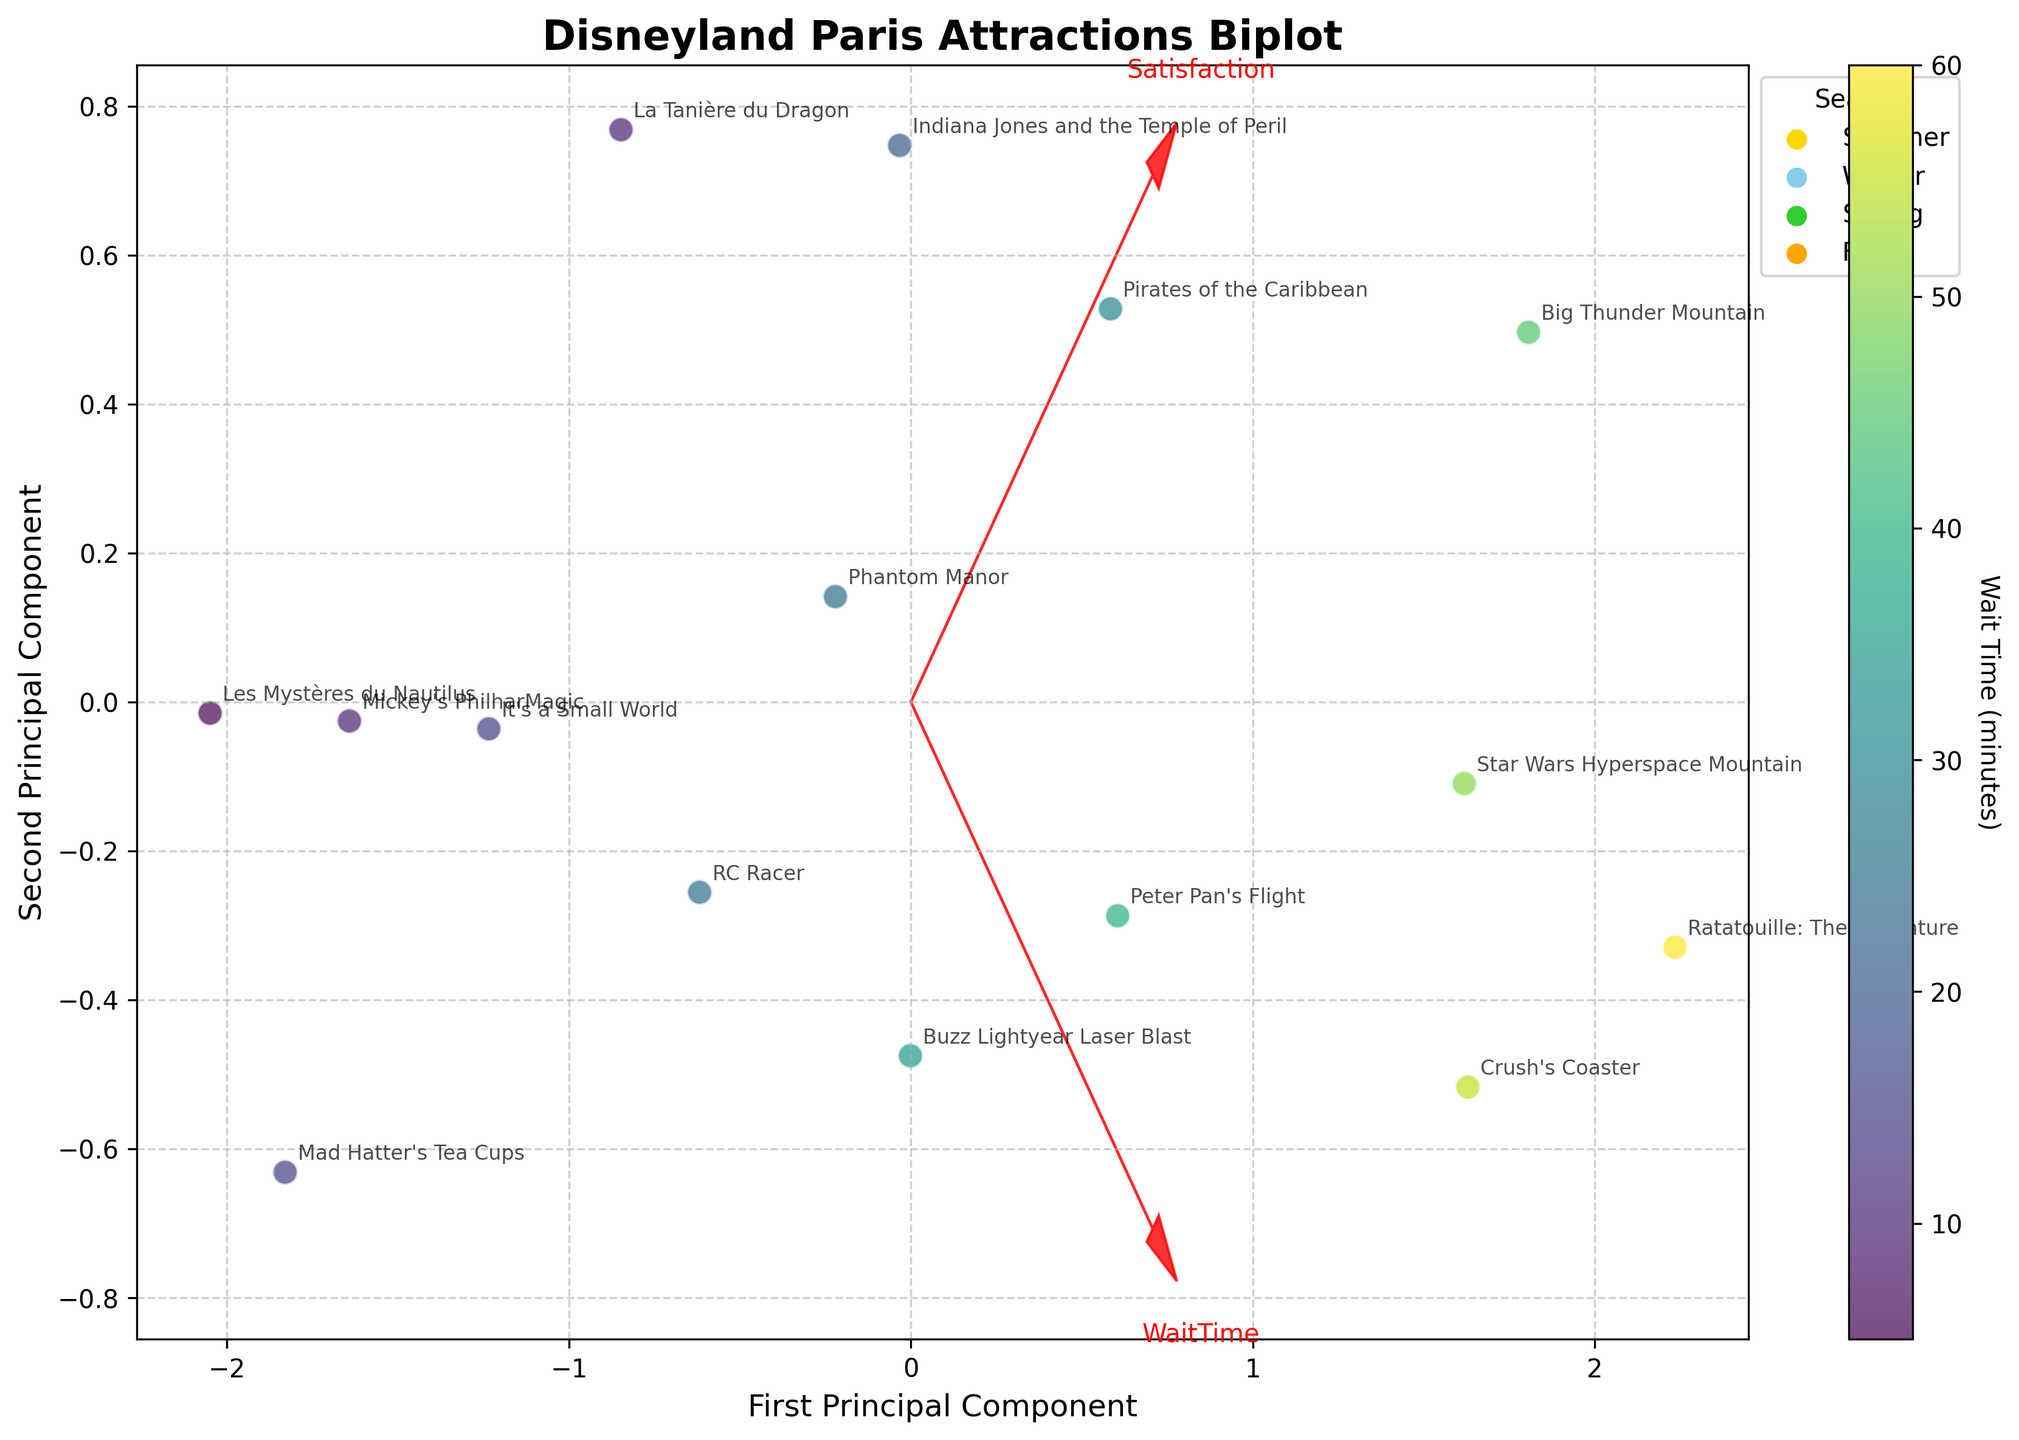What does the arrow represent in the biplot? The arrows in the biplot represent the directions of the features (Satisfaction and WaitTime) in the new principal component space. Each arrow points in the direction of the greatest variance for that feature.
Answer: Feature direction How can we identify which attractions have the highest satisfaction ratings? In the biplot, data points representing attractions can be identified with their labels. The position of each point along the axis direction helps in identifying their corresponding satisfaction ratings. Attractions positioned farther in the direction of the arrow labeled "Satisfaction" have higher satisfaction ratings.
Answer: By looking at the position along the Satisfaction direction How does 'Big Thunder Mountain' compare to 'Peter Pan's Flight' in terms of wait time? The biplot allows us to compare wait times by observing their positions relative to the "WaitTime" arrow. 'Big Thunder Mountain' and 'Peter Pan's Flight' can be compared by seeing which point is closer to the end of the "WaitTime" arrow. 'Big Thunder Mountain' is closer to the high end of the wait time direction compared to 'Peter Pan's Flight'.
Answer: 'Big Thunder Mountain' has a higher wait time Which season has the most data points in the biplot? The color legend indicates different seasons with distinctive colors. Counting the number of data points per color in the scatter plot, the season with the most points can be identified.
Answer: Summer Why does 'Les Mystères du Nautilus' have a lower satisfaction rating compared to 'Star Wars Hyperspace Mountain'? From the biplot, compare the relative positions of the data points labeled 'Les Mystères du Nautilus' and 'Star Wars Hyperspace Mountain' along the Satisfaction direction. 'Les Mystères du Nautilus' is positioned lower in the satisfaction direction compared to 'Star Wars Hyperspace Mountain'.
Answer: It is positioned lower in the Satisfaction direction What can be inferred about wait times for attractions in different seasons? By observing the biplot with the attractor points color-coded by season, it is possible to determine if certain seasons have generally longer or shorter wait times based on their positions along the WaitTime direction.
Answer: Seasonal distribution of wait times can be inferred from positions Which attraction has the highest satisfaction but the lowest wait time? In the biplot, the attraction with the highest satisfaction rating and lowest wait time would be located far along the Satisfaction direction but near the origin of the WaitTime direction.
Answer: 'Indiana Jones and the Temple of Peril' Do food enthusiasts tend to rate attractions higher or lower compared to other visitor types? Observing the biplot, locate attractions with labels indicating food enthusiasts and compare their positions along the Satisfaction direction against other visitor types.
Answer: They tend to rate attractions higher What's the general trend between satisfaction and wait time in the biplot? Observing the slopes and directions of the points in relation to both the Satisfaction and WaitTime arrows, a trend can be identified. A general positive or negative slope indicates a trend between the two variables.
Answer: Positive association How are the attractions for 'Families' distributed on the biplot compared to 'Thrill-seekers'? Locate and compare the positions of points labeled under 'Families' and 'Thrill-seekers' along the Satisfaction and WaitTime directions.
Answer: 'Thrill-seekers' attractions tend to be higher on both Satisfaction and Wait time 